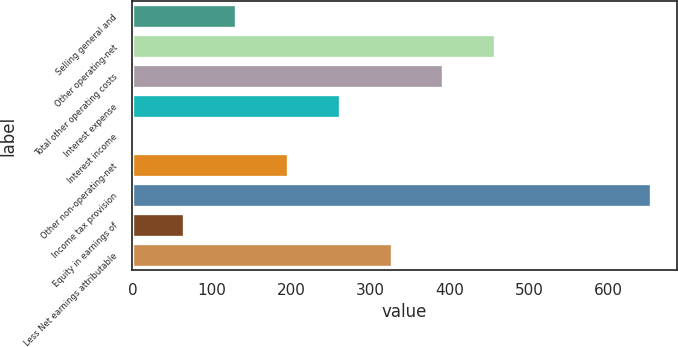Convert chart to OTSL. <chart><loc_0><loc_0><loc_500><loc_500><bar_chart><fcel>Selling general and<fcel>Other operating-net<fcel>Total other operating costs<fcel>Interest expense<fcel>Interest income<fcel>Other non-operating-net<fcel>Income tax provision<fcel>Equity in earnings of<fcel>Less Net earnings attributable<nl><fcel>130.72<fcel>457.02<fcel>391.76<fcel>261.24<fcel>0.2<fcel>195.98<fcel>652.8<fcel>65.46<fcel>326.5<nl></chart> 